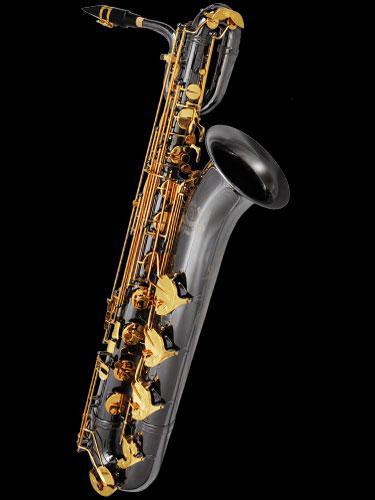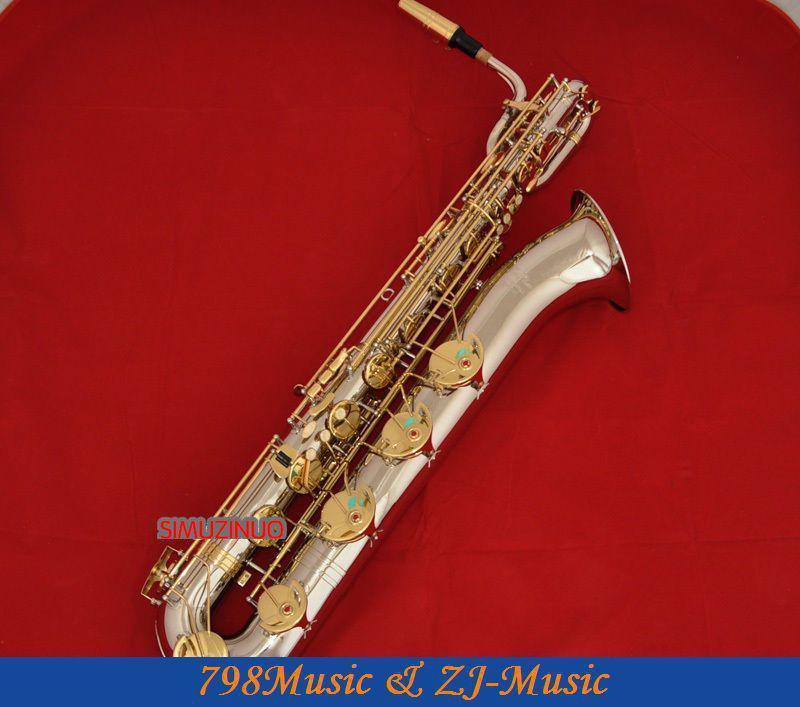The first image is the image on the left, the second image is the image on the right. For the images shown, is this caption "The left and right image contains the same number of  fully sized saxophones." true? Answer yes or no. Yes. 